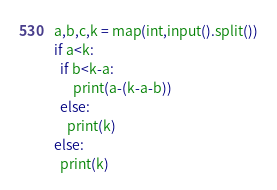<code> <loc_0><loc_0><loc_500><loc_500><_Python_>a,b,c,k = map(int,input().split())
if a<k:
  if b<k-a:
      print(a-(k-a-b))
  else:
    print(k)    
else:
  print(k)</code> 